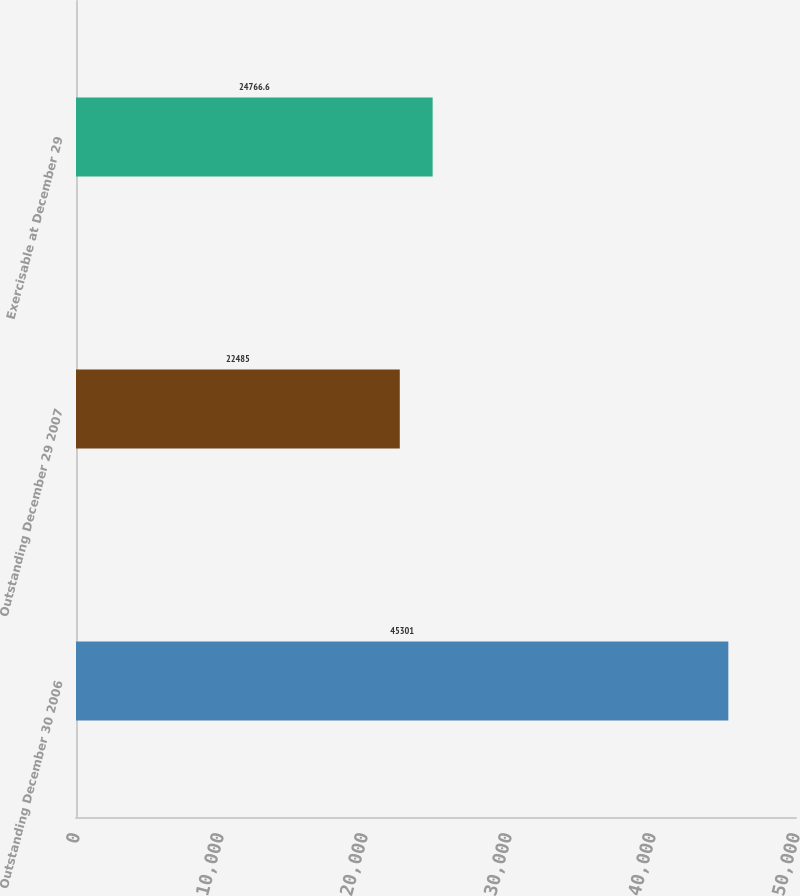Convert chart to OTSL. <chart><loc_0><loc_0><loc_500><loc_500><bar_chart><fcel>Outstanding December 30 2006<fcel>Outstanding December 29 2007<fcel>Exercisable at December 29<nl><fcel>45301<fcel>22485<fcel>24766.6<nl></chart> 